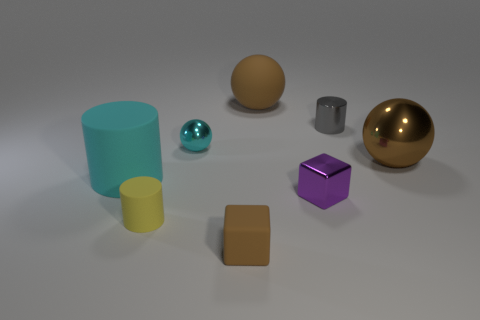Add 2 tiny yellow matte cylinders. How many objects exist? 10 Subtract all cylinders. How many objects are left? 5 Add 2 big cyan things. How many big cyan things are left? 3 Add 1 brown metallic spheres. How many brown metallic spheres exist? 2 Subtract 1 cyan spheres. How many objects are left? 7 Subtract all purple things. Subtract all tiny purple things. How many objects are left? 6 